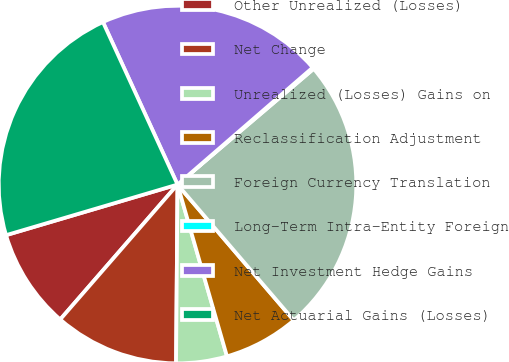<chart> <loc_0><loc_0><loc_500><loc_500><pie_chart><fcel>Other Unrealized (Losses)<fcel>Net Change<fcel>Unrealized (Losses) Gains on<fcel>Reclassification Adjustment<fcel>Foreign Currency Translation<fcel>Long-Term Intra-Entity Foreign<fcel>Net Investment Hedge Gains<fcel>Net Actuarial Gains (Losses)<nl><fcel>9.04%<fcel>11.26%<fcel>4.59%<fcel>6.81%<fcel>24.94%<fcel>0.14%<fcel>20.49%<fcel>22.72%<nl></chart> 